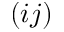Convert formula to latex. <formula><loc_0><loc_0><loc_500><loc_500>( i j )</formula> 